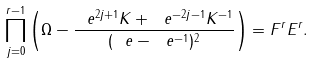Convert formula to latex. <formula><loc_0><loc_0><loc_500><loc_500>\prod _ { j = 0 } ^ { r - 1 } \left ( \Omega - \frac { \ e ^ { 2 j + 1 } K + \ e ^ { - 2 j - 1 } K ^ { - 1 } } { ( \ e - \ e ^ { - 1 } ) ^ { 2 } } \right ) = F ^ { r } E ^ { r } .</formula> 